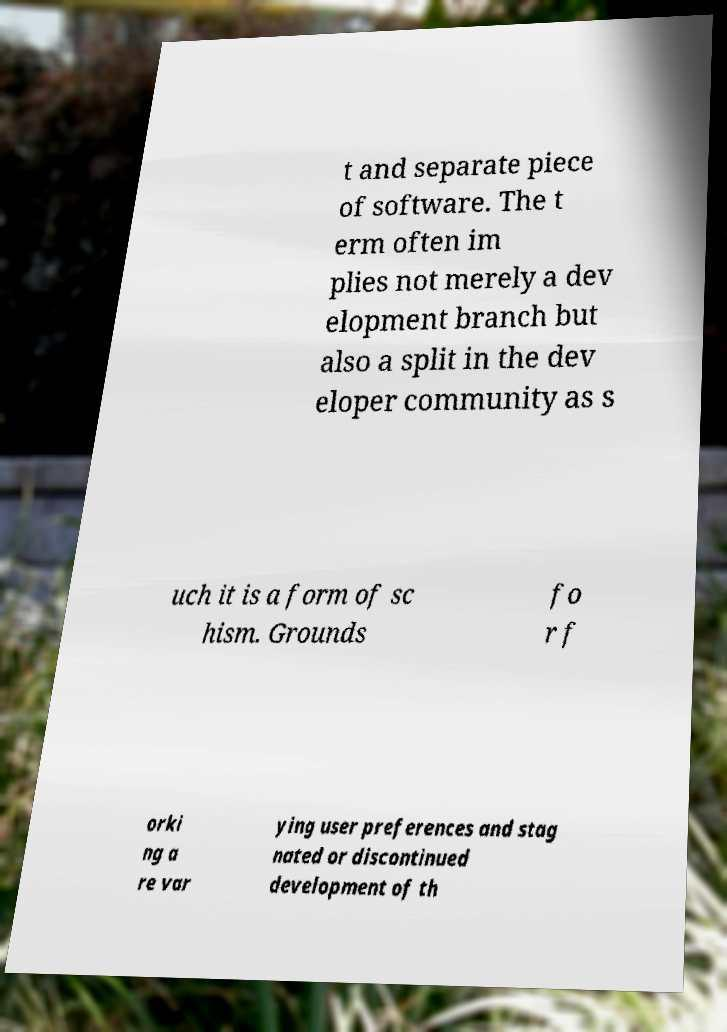What messages or text are displayed in this image? I need them in a readable, typed format. t and separate piece of software. The t erm often im plies not merely a dev elopment branch but also a split in the dev eloper community as s uch it is a form of sc hism. Grounds fo r f orki ng a re var ying user preferences and stag nated or discontinued development of th 